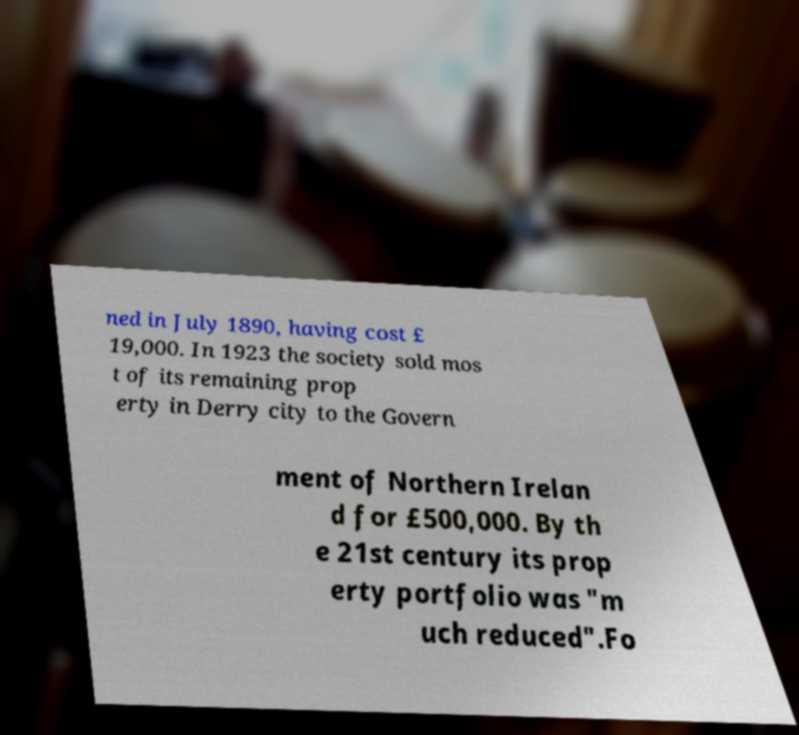There's text embedded in this image that I need extracted. Can you transcribe it verbatim? ned in July 1890, having cost £ 19,000. In 1923 the society sold mos t of its remaining prop erty in Derry city to the Govern ment of Northern Irelan d for £500,000. By th e 21st century its prop erty portfolio was "m uch reduced".Fo 